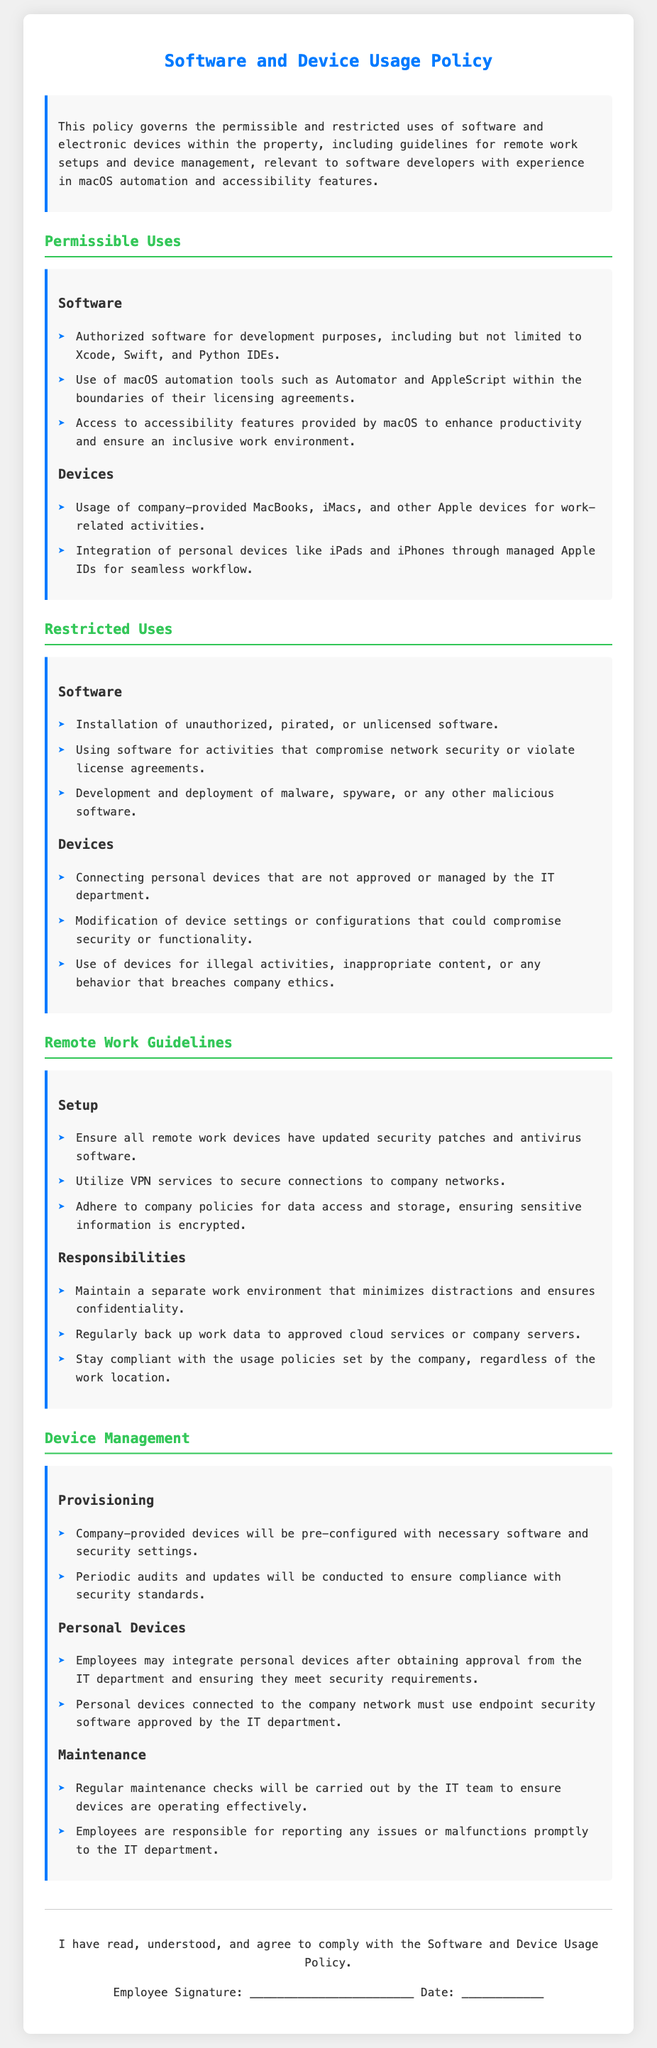What software is authorized for development purposes? The document lists authorized software for development purposes including Xcode, Swift, and Python IDEs.
Answer: Xcode, Swift, Python IDEs What must be updated on remote work devices? The document states that all remote work devices must have updated security patches and antivirus software.
Answer: Security patches, antivirus software Are personal devices allowed to connect to the company network? The document specifies that employees may integrate personal devices after obtaining approval from the IT department.
Answer: Yes, with approval What is prohibited regarding software installation? The document explicitly states that the installation of unauthorized, pirated, or unlicensed software is prohibited.
Answer: Unauthorized, pirated, unlicensed software What should employees do if they experience device malfunctions? According to the document, employees are responsible for reporting issues or malfunctions promptly to the IT department.
Answer: Report to IT department What will company-provided devices be pre-configured with? The document indicates that company-provided devices will be pre-configured with necessary software and security settings.
Answer: Necessary software, security settings What connection method should be used for securing remote work? The document recommends utilizing VPN services to secure connections to company networks.
Answer: VPN services How often will audits and updates be conducted? The document mentions that periodic audits and updates will be conducted to ensure compliance with security standards.
Answer: Periodically 